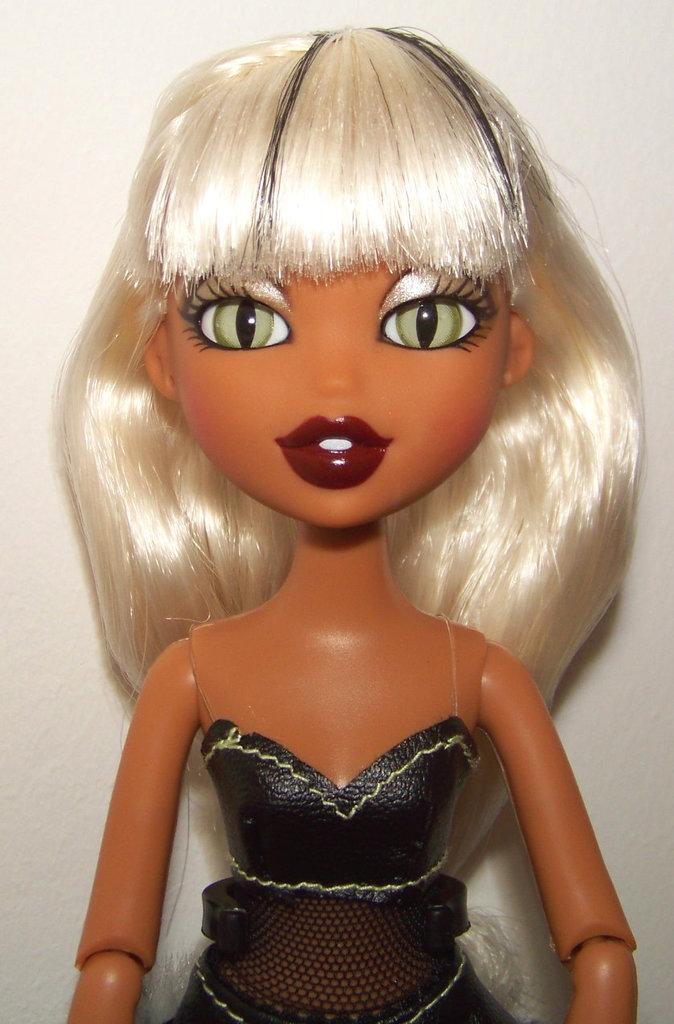Can you describe this image briefly? In the image we can see a doll. Behind the doll where is wall. 